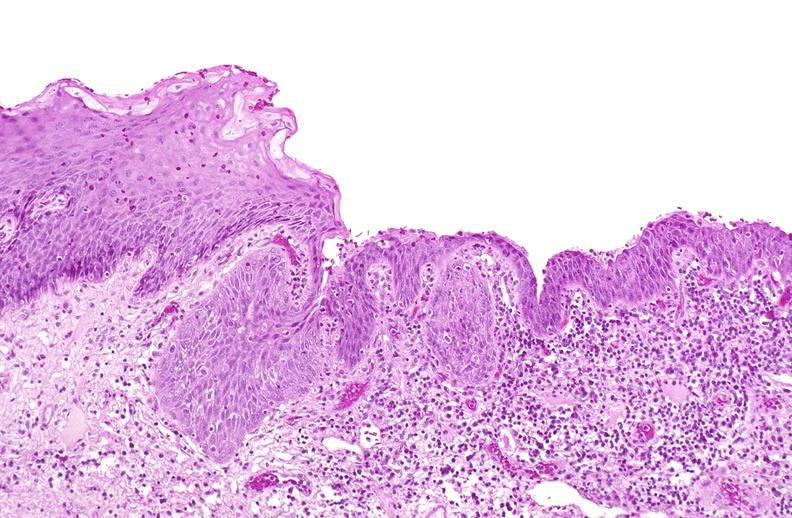s all the fat necrosis present?
Answer the question using a single word or phrase. No 